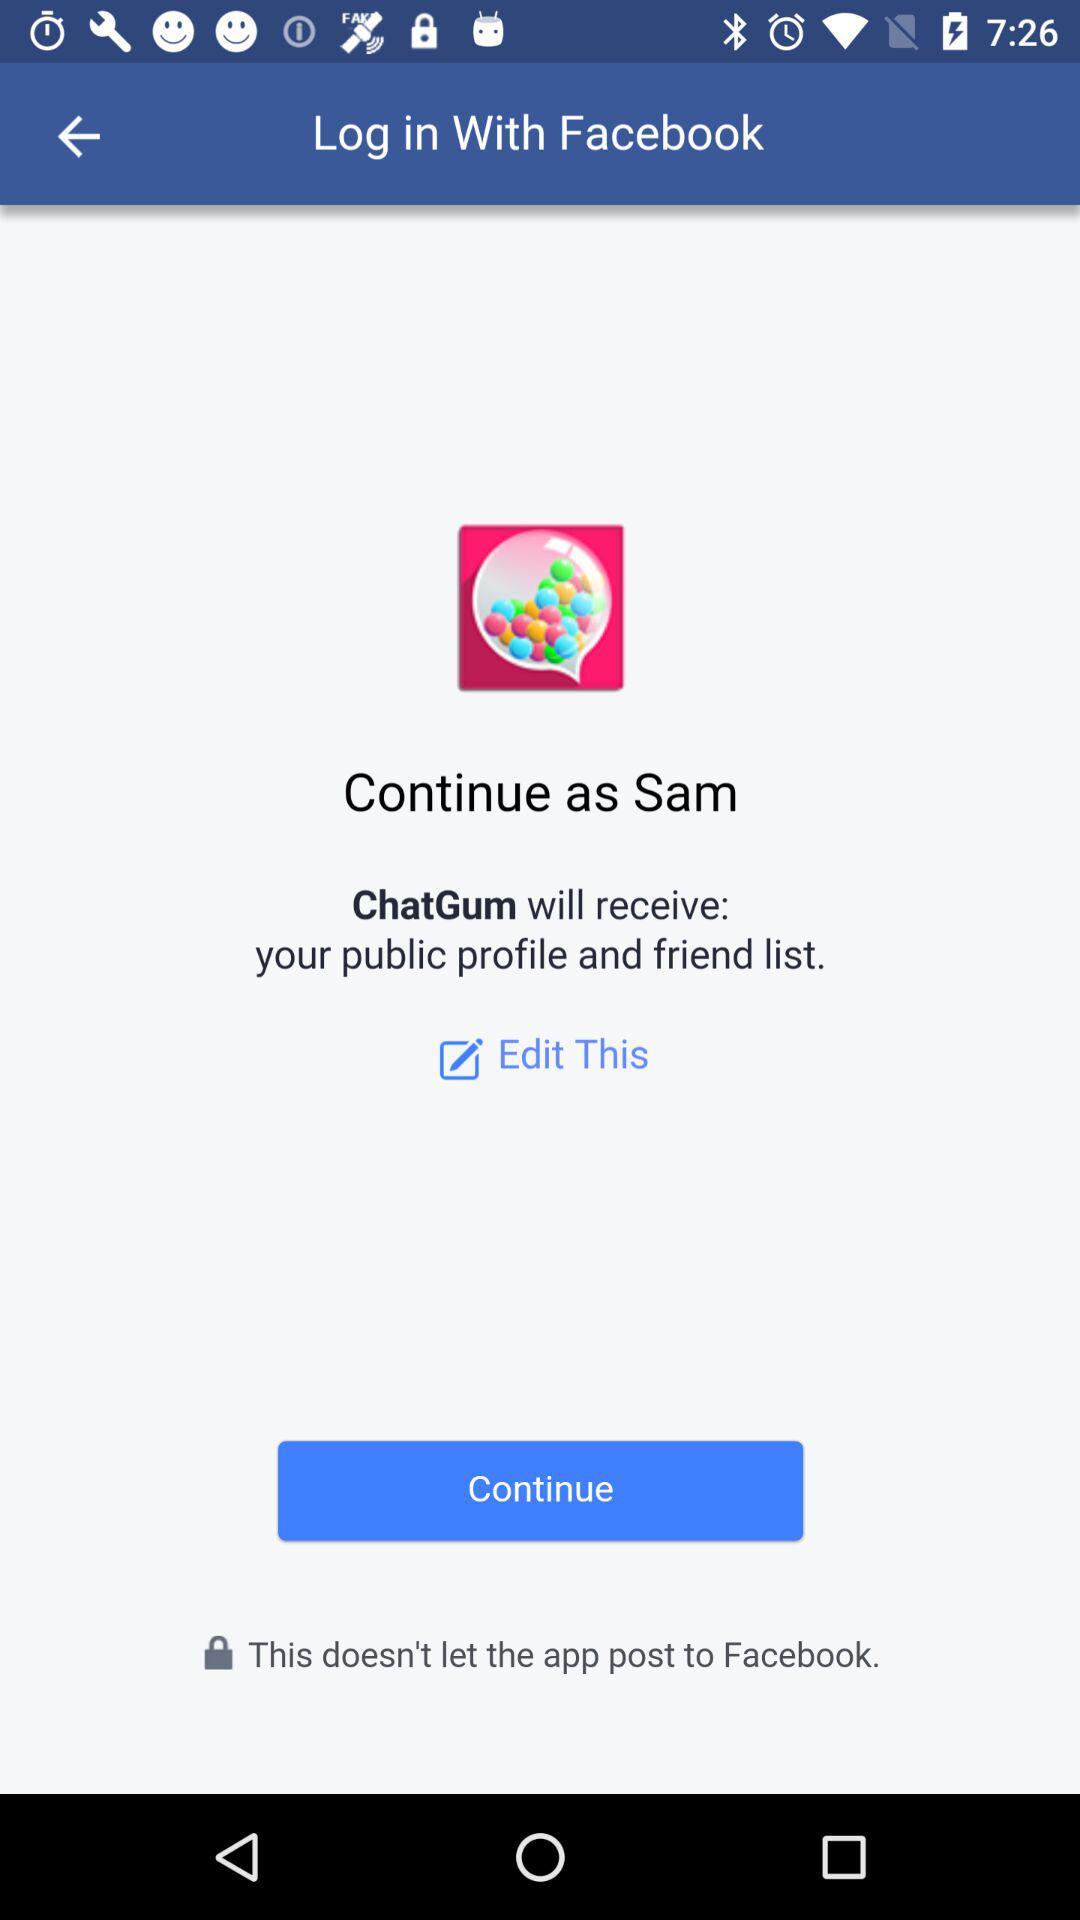What is the name of the user? The name of the user is Sam. 